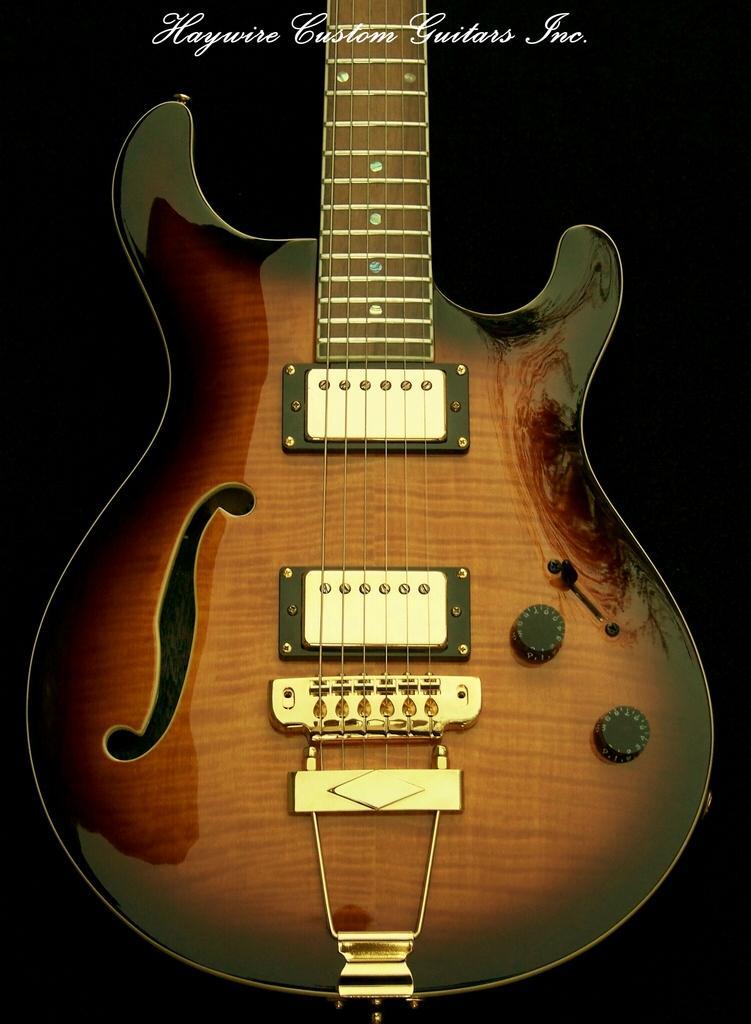How would you summarize this image in a sentence or two? In this picture there is a guitar which is brown in color. A black border is seen on the guitar. There are six strings in the guitar. 